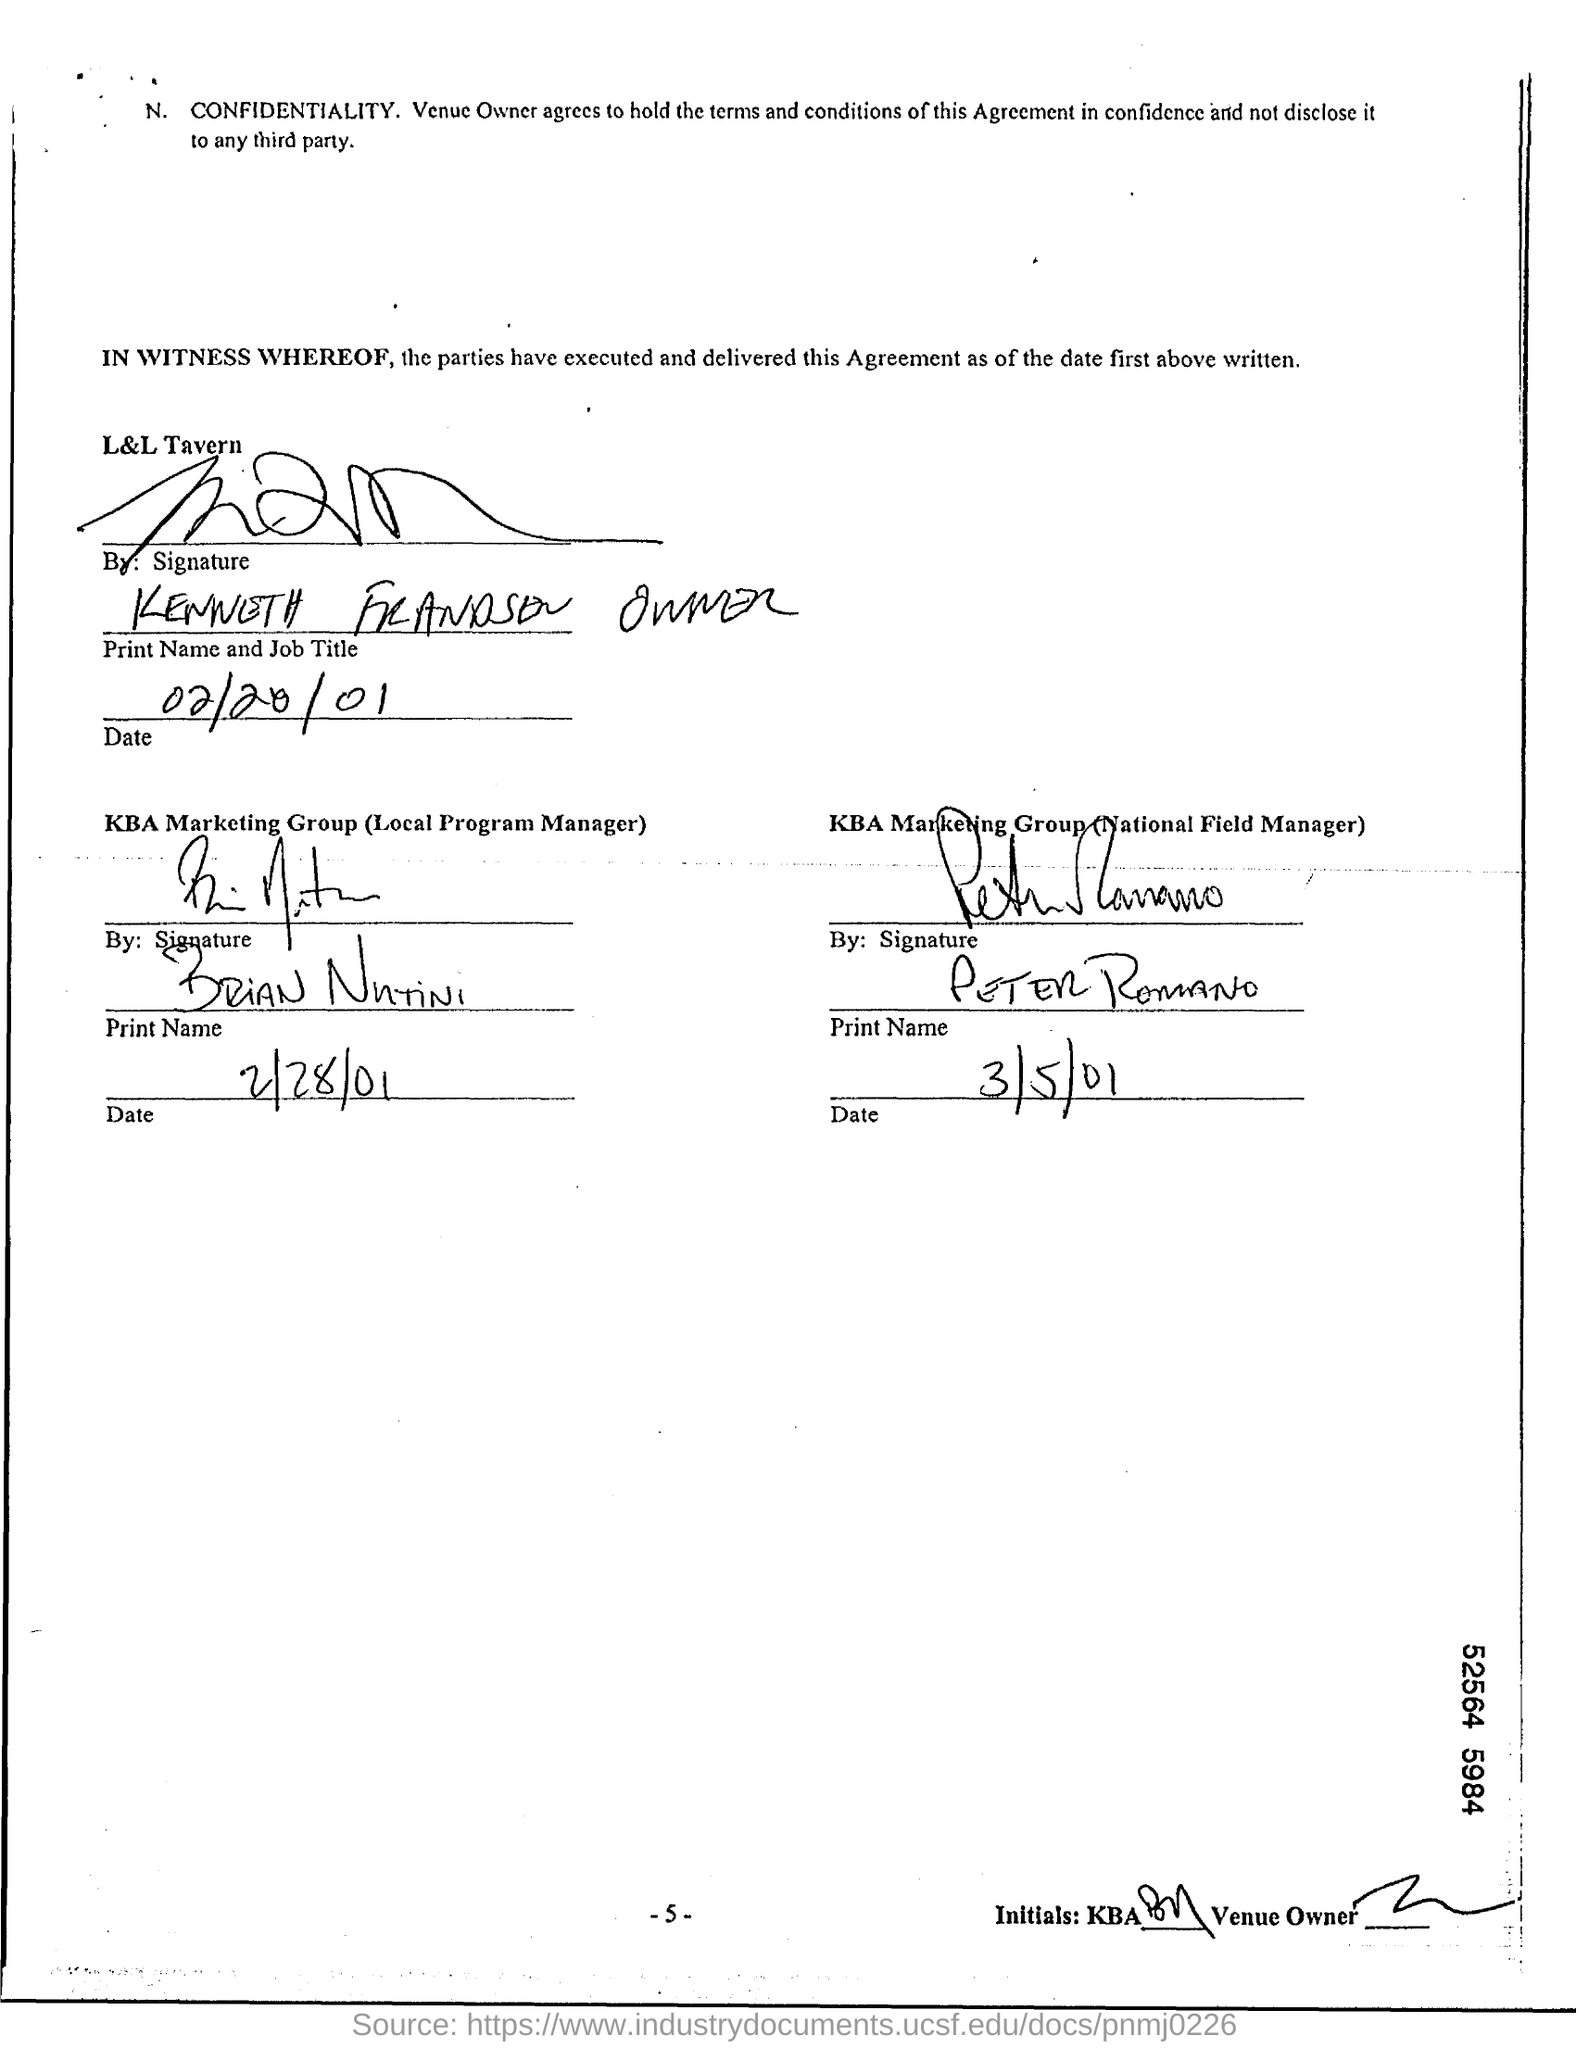What is the date written for L&L Tavern?
Your answer should be very brief. 02/20/01. What is the Local Program Manager's name of KBA Marketing Group?
Keep it short and to the point. Brian Nutini. What is the date mentioned under KBA Marketing Group (Local Program Manager) ?
Provide a short and direct response. 2/28/01. What is the name of National Field Manager, KBA Marketing Group ?
Offer a terse response. PETER ROMANO. What is the date written under KBA Marketing Group (National Field Manager) ?
Provide a short and direct response. 3/5/01. 